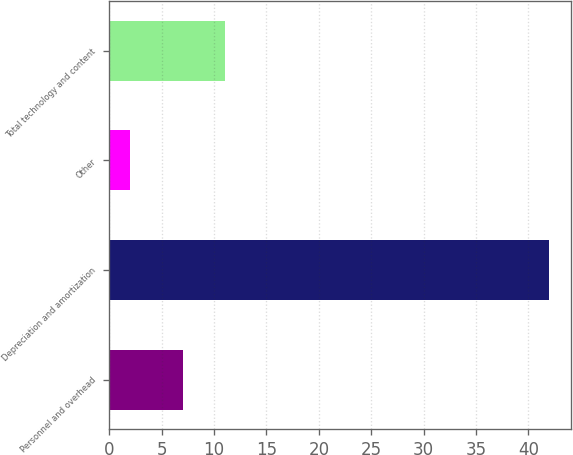Convert chart. <chart><loc_0><loc_0><loc_500><loc_500><bar_chart><fcel>Personnel and overhead<fcel>Depreciation and amortization<fcel>Other<fcel>Total technology and content<nl><fcel>7<fcel>42<fcel>2<fcel>11<nl></chart> 